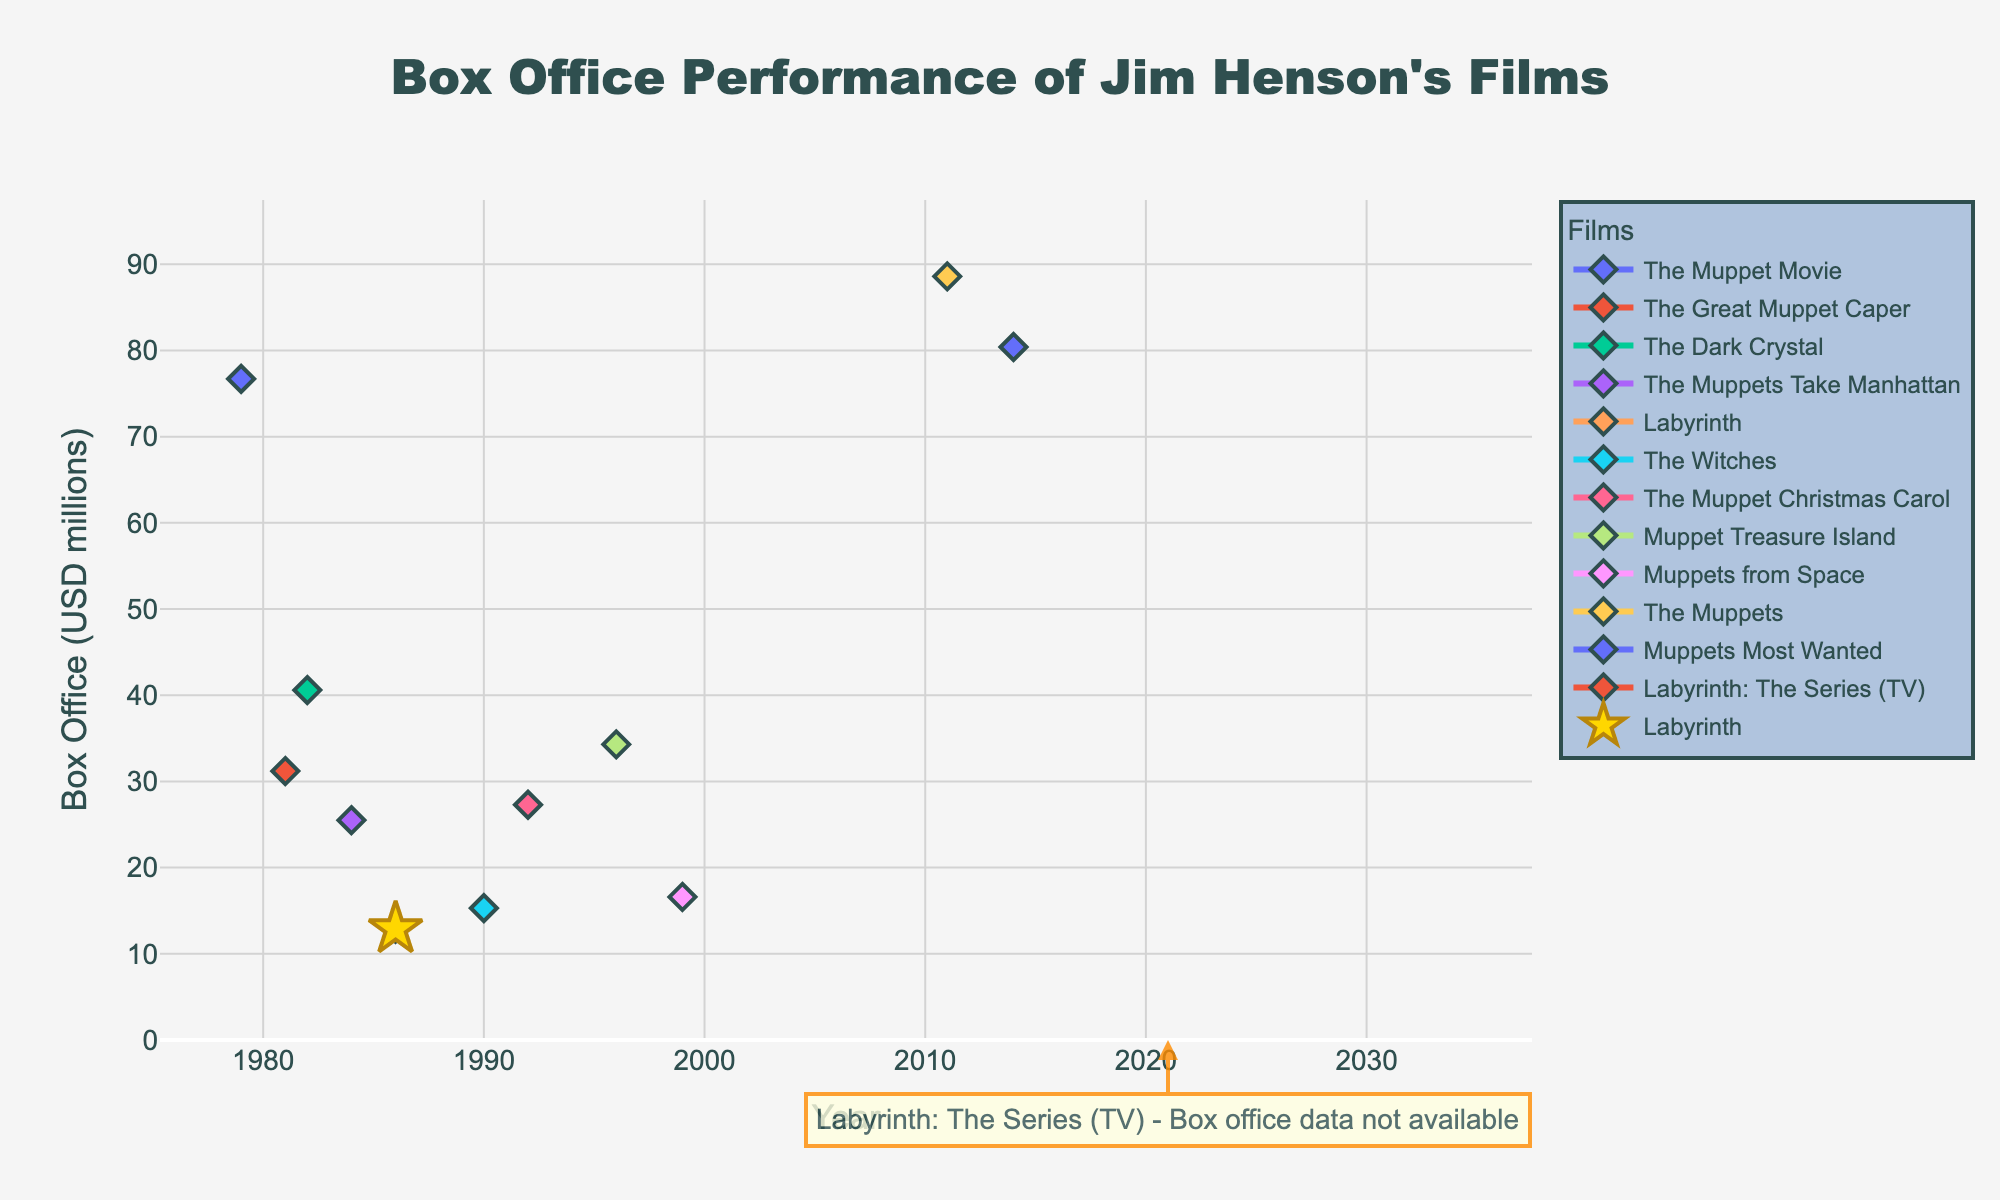What is the box office performance of "Labyrinth" compared to "The Muppets Take Manhattan"? To compare the box office performance of "Labyrinth" and "The Muppets Take Manhattan", locate the two points on the plot. "Labyrinth" generated $12.9 million in 1986, while "The Muppets Take Manhattan" generated $25.5 million in 1984.
Answer: "The Muppets Take Manhattan" ($25.5 million) had a higher box office performance than "Labyrinth" ($12.9 million) Which film has the highest box office revenue and what is the value? Look for the highest point on the plot. "The Muppets" in 2011 has the highest box office revenue with $88.6 million.
Answer: "The Muppets" ($88.6 million) How does the box office performance of "Labyrinth: The Series" compare to the other films? Check the annotation for "Labyrinth: The Series" which states that box office data is not available for the TV series, making it incomparable.
Answer: Data not available What is the average box office performance of all Jim Henson films, excluding "Labyrinth"? Sum the box office revenues of all films excluding "Labyrinth" and divide by the number of those films. Sum = 76.7 + 31.2 + 40.6 + 25.5 + 15.3 + 27.3 + 34.3 + 16.6 + 88.6 + 80.4 = 436.5. Number of films = 10. Average = 436.5 / 10 = 43.65
Answer: $43.65 million Did any other film besides "Labyrinth" have a box office performance lower than $25 million? Locate any points below $25 million on the plot. "The Witches" ($15.3 million) and "Muppets from Space" ($16.6 million) are the other films below this threshold.
Answer: Yes, "The Witches" and "Muppets from Space" Between "The Dark Crystal" and "Labyrinth", which film performed better at the box office and by how much? Compare the revenues: "The Dark Crystal" ($40.6 million) and "Labyrinth" ($12.9 million). Difference = 40.6 - 12.9 = 27.7.
Answer: "The Dark Crystal" performed better by $27.7 million Which film experienced a noticeable upward trend after "Labyrinth"? Identify the films released after "Labyrinth" in 1986 and observe the plot for any film with an increasing trend in box office performance. "The Muppet Christmas Carol" released in 1992 shows an upward trend.
Answer: "The Muppet Christmas Carol" Which year correlates with the lowest box office performance for Jim Henson's films, excluding "Labyrinth"? Find the lowest point on the plot, excluding "Labyrinth". The lowest performance is "The Witches" in 1990 with $15.3 million.
Answer: 1990 If you average the box office revenues for the top 3 performing films, what is the result? Identify the top 3 films: "The Muppets" ($88.6 million), "Muppets Most Wanted" ($80.4 million), and "The Muppet Movie" ($76.7 million). Sum = 88.6 + 80.4 + 76.7 = 245.7. Average = 245.7 / 3 = 81.9.
Answer: $81.9 million 